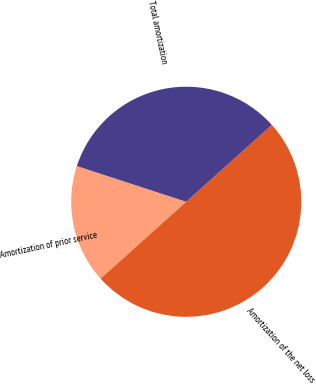Convert chart to OTSL. <chart><loc_0><loc_0><loc_500><loc_500><pie_chart><fcel>Amortization of prior service<fcel>Amortization of the net loss<fcel>Total amortization<nl><fcel>16.67%<fcel>50.0%<fcel>33.33%<nl></chart> 